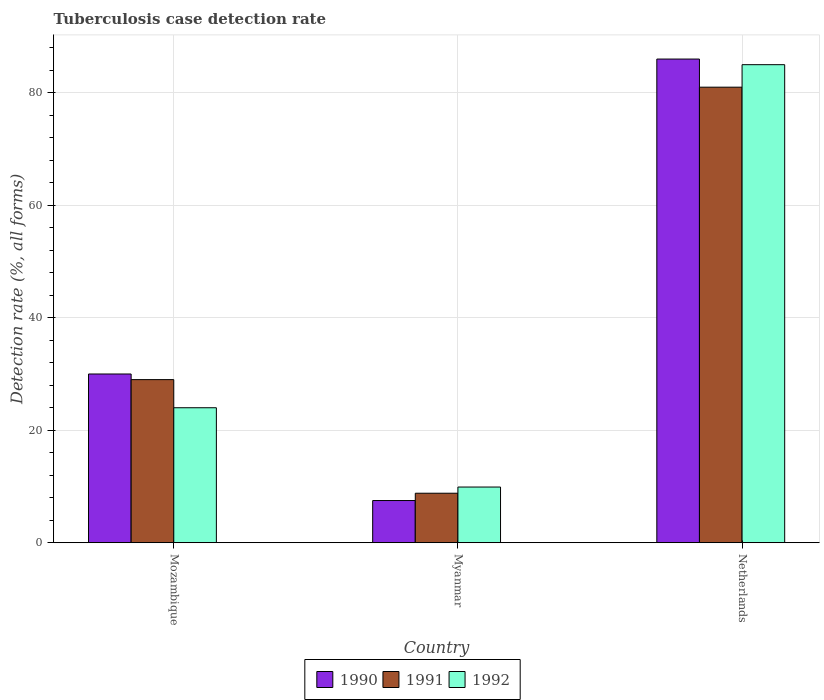Are the number of bars per tick equal to the number of legend labels?
Make the answer very short. Yes. Are the number of bars on each tick of the X-axis equal?
Give a very brief answer. Yes. What is the label of the 1st group of bars from the left?
Offer a terse response. Mozambique. Across all countries, what is the maximum tuberculosis case detection rate in in 1991?
Keep it short and to the point. 81. Across all countries, what is the minimum tuberculosis case detection rate in in 1992?
Ensure brevity in your answer.  9.9. In which country was the tuberculosis case detection rate in in 1991 minimum?
Ensure brevity in your answer.  Myanmar. What is the total tuberculosis case detection rate in in 1992 in the graph?
Your answer should be compact. 118.9. What is the difference between the tuberculosis case detection rate in in 1992 in Mozambique and the tuberculosis case detection rate in in 1990 in Netherlands?
Ensure brevity in your answer.  -62. What is the average tuberculosis case detection rate in in 1990 per country?
Offer a terse response. 41.17. In how many countries, is the tuberculosis case detection rate in in 1990 greater than 32 %?
Make the answer very short. 1. What is the ratio of the tuberculosis case detection rate in in 1990 in Myanmar to that in Netherlands?
Provide a succinct answer. 0.09. What is the difference between the highest and the lowest tuberculosis case detection rate in in 1992?
Your answer should be compact. 75.1. In how many countries, is the tuberculosis case detection rate in in 1991 greater than the average tuberculosis case detection rate in in 1991 taken over all countries?
Provide a succinct answer. 1. What does the 2nd bar from the left in Netherlands represents?
Offer a very short reply. 1991. What does the 1st bar from the right in Mozambique represents?
Offer a terse response. 1992. How many bars are there?
Keep it short and to the point. 9. Are all the bars in the graph horizontal?
Make the answer very short. No. How many countries are there in the graph?
Ensure brevity in your answer.  3. What is the difference between two consecutive major ticks on the Y-axis?
Make the answer very short. 20. Are the values on the major ticks of Y-axis written in scientific E-notation?
Offer a terse response. No. Where does the legend appear in the graph?
Ensure brevity in your answer.  Bottom center. How are the legend labels stacked?
Make the answer very short. Horizontal. What is the title of the graph?
Make the answer very short. Tuberculosis case detection rate. What is the label or title of the Y-axis?
Offer a terse response. Detection rate (%, all forms). What is the Detection rate (%, all forms) in 1990 in Mozambique?
Keep it short and to the point. 30. What is the Detection rate (%, all forms) in 1991 in Mozambique?
Ensure brevity in your answer.  29. What is the Detection rate (%, all forms) in 1992 in Mozambique?
Provide a succinct answer. 24. What is the Detection rate (%, all forms) of 1990 in Myanmar?
Provide a succinct answer. 7.5. What is the Detection rate (%, all forms) in 1991 in Netherlands?
Make the answer very short. 81. What is the Detection rate (%, all forms) of 1992 in Netherlands?
Offer a terse response. 85. Across all countries, what is the maximum Detection rate (%, all forms) in 1992?
Ensure brevity in your answer.  85. What is the total Detection rate (%, all forms) of 1990 in the graph?
Your response must be concise. 123.5. What is the total Detection rate (%, all forms) in 1991 in the graph?
Give a very brief answer. 118.8. What is the total Detection rate (%, all forms) of 1992 in the graph?
Your response must be concise. 118.9. What is the difference between the Detection rate (%, all forms) in 1990 in Mozambique and that in Myanmar?
Offer a very short reply. 22.5. What is the difference between the Detection rate (%, all forms) of 1991 in Mozambique and that in Myanmar?
Ensure brevity in your answer.  20.2. What is the difference between the Detection rate (%, all forms) of 1990 in Mozambique and that in Netherlands?
Make the answer very short. -56. What is the difference between the Detection rate (%, all forms) of 1991 in Mozambique and that in Netherlands?
Provide a succinct answer. -52. What is the difference between the Detection rate (%, all forms) in 1992 in Mozambique and that in Netherlands?
Ensure brevity in your answer.  -61. What is the difference between the Detection rate (%, all forms) of 1990 in Myanmar and that in Netherlands?
Give a very brief answer. -78.5. What is the difference between the Detection rate (%, all forms) of 1991 in Myanmar and that in Netherlands?
Provide a succinct answer. -72.2. What is the difference between the Detection rate (%, all forms) of 1992 in Myanmar and that in Netherlands?
Provide a short and direct response. -75.1. What is the difference between the Detection rate (%, all forms) of 1990 in Mozambique and the Detection rate (%, all forms) of 1991 in Myanmar?
Make the answer very short. 21.2. What is the difference between the Detection rate (%, all forms) in 1990 in Mozambique and the Detection rate (%, all forms) in 1992 in Myanmar?
Your response must be concise. 20.1. What is the difference between the Detection rate (%, all forms) of 1990 in Mozambique and the Detection rate (%, all forms) of 1991 in Netherlands?
Ensure brevity in your answer.  -51. What is the difference between the Detection rate (%, all forms) of 1990 in Mozambique and the Detection rate (%, all forms) of 1992 in Netherlands?
Offer a very short reply. -55. What is the difference between the Detection rate (%, all forms) of 1991 in Mozambique and the Detection rate (%, all forms) of 1992 in Netherlands?
Offer a very short reply. -56. What is the difference between the Detection rate (%, all forms) of 1990 in Myanmar and the Detection rate (%, all forms) of 1991 in Netherlands?
Your answer should be compact. -73.5. What is the difference between the Detection rate (%, all forms) in 1990 in Myanmar and the Detection rate (%, all forms) in 1992 in Netherlands?
Offer a terse response. -77.5. What is the difference between the Detection rate (%, all forms) in 1991 in Myanmar and the Detection rate (%, all forms) in 1992 in Netherlands?
Ensure brevity in your answer.  -76.2. What is the average Detection rate (%, all forms) in 1990 per country?
Offer a terse response. 41.17. What is the average Detection rate (%, all forms) of 1991 per country?
Provide a short and direct response. 39.6. What is the average Detection rate (%, all forms) in 1992 per country?
Your answer should be compact. 39.63. What is the difference between the Detection rate (%, all forms) of 1991 and Detection rate (%, all forms) of 1992 in Mozambique?
Your answer should be very brief. 5. What is the difference between the Detection rate (%, all forms) in 1990 and Detection rate (%, all forms) in 1992 in Myanmar?
Provide a succinct answer. -2.4. What is the difference between the Detection rate (%, all forms) of 1990 and Detection rate (%, all forms) of 1991 in Netherlands?
Offer a very short reply. 5. What is the difference between the Detection rate (%, all forms) in 1990 and Detection rate (%, all forms) in 1992 in Netherlands?
Provide a succinct answer. 1. What is the difference between the Detection rate (%, all forms) in 1991 and Detection rate (%, all forms) in 1992 in Netherlands?
Provide a short and direct response. -4. What is the ratio of the Detection rate (%, all forms) of 1991 in Mozambique to that in Myanmar?
Offer a terse response. 3.3. What is the ratio of the Detection rate (%, all forms) in 1992 in Mozambique to that in Myanmar?
Ensure brevity in your answer.  2.42. What is the ratio of the Detection rate (%, all forms) of 1990 in Mozambique to that in Netherlands?
Your answer should be compact. 0.35. What is the ratio of the Detection rate (%, all forms) of 1991 in Mozambique to that in Netherlands?
Give a very brief answer. 0.36. What is the ratio of the Detection rate (%, all forms) in 1992 in Mozambique to that in Netherlands?
Keep it short and to the point. 0.28. What is the ratio of the Detection rate (%, all forms) of 1990 in Myanmar to that in Netherlands?
Your response must be concise. 0.09. What is the ratio of the Detection rate (%, all forms) of 1991 in Myanmar to that in Netherlands?
Provide a succinct answer. 0.11. What is the ratio of the Detection rate (%, all forms) of 1992 in Myanmar to that in Netherlands?
Offer a very short reply. 0.12. What is the difference between the highest and the second highest Detection rate (%, all forms) in 1990?
Offer a terse response. 56. What is the difference between the highest and the lowest Detection rate (%, all forms) in 1990?
Offer a very short reply. 78.5. What is the difference between the highest and the lowest Detection rate (%, all forms) in 1991?
Your answer should be compact. 72.2. What is the difference between the highest and the lowest Detection rate (%, all forms) in 1992?
Provide a succinct answer. 75.1. 